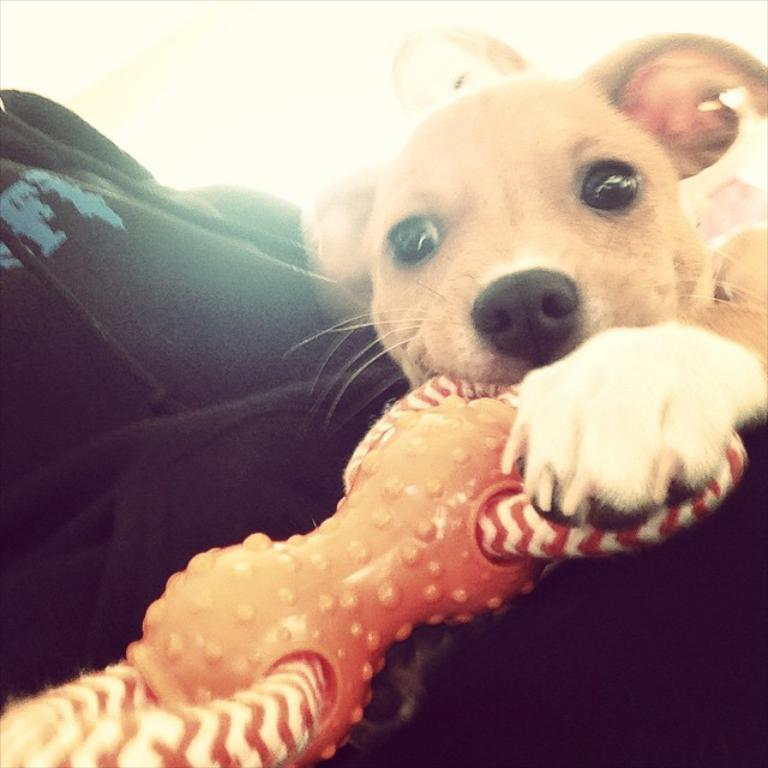What animal can be seen in the image? There is a dog in the image. What is the dog doing with its mouth? The dog is holding a toy in its mouth. What type of clothing is visible in the image? There is a black color jacket in the image. Who is present behind the dog? There is a girl behind the dog. What color is the background of the image? The background of the image is white in color. What type of substance is the dog chewing on in the image? There is no substance visible in the image; the dog is holding a toy in its mouth. 